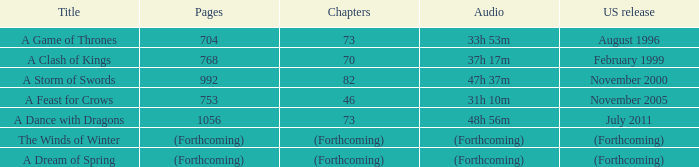Which title has a us premiere in august 1996? A Game of Thrones. 